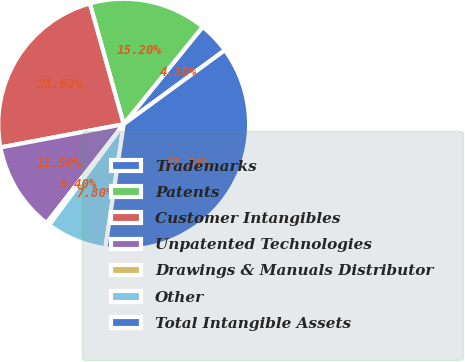Convert chart to OTSL. <chart><loc_0><loc_0><loc_500><loc_500><pie_chart><fcel>Trademarks<fcel>Patents<fcel>Customer Intangibles<fcel>Unpatented Technologies<fcel>Drawings & Manuals Distributor<fcel>Other<fcel>Total Intangible Assets<nl><fcel>4.1%<fcel>15.2%<fcel>23.62%<fcel>11.5%<fcel>0.4%<fcel>7.8%<fcel>37.39%<nl></chart> 